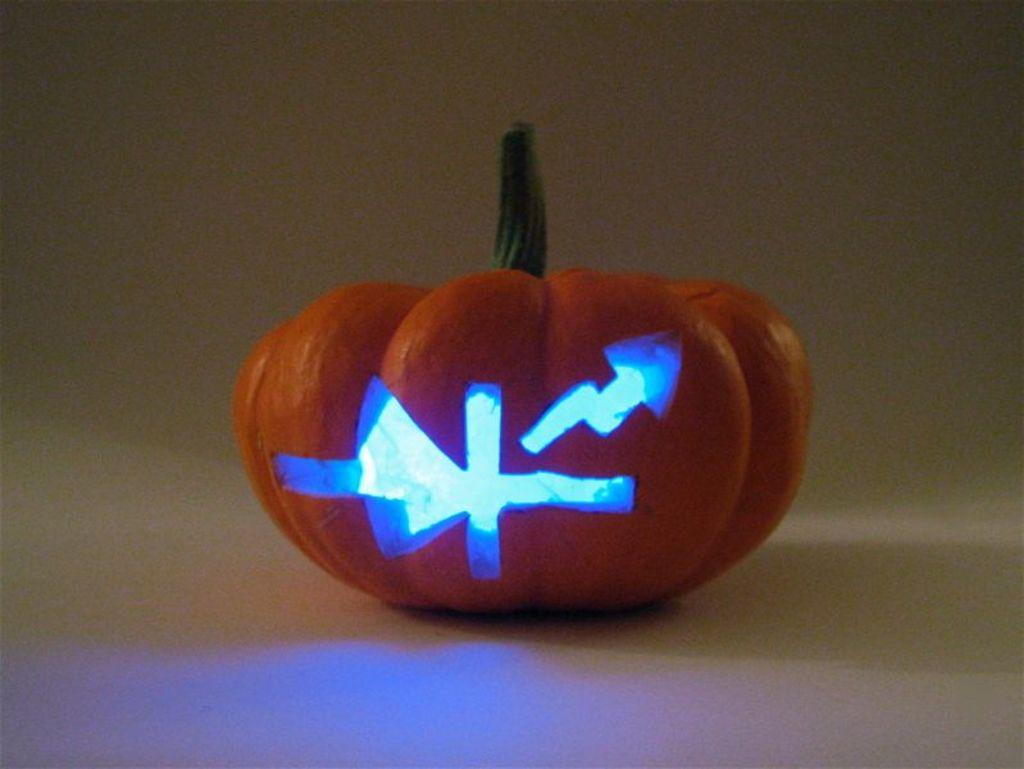What is the main subject of the image? The main subject of the image is a fruit. What is the color of the fruit? The fruit is in orange color. What color is the background of the image? The background of the image is white. How does the fruit adjust its position in the image? The fruit does not adjust its position in the image; it is stationary. Can you tell me how many friends the fruit has in the image? There are no friends present in the image, as the image only features a fruit. 